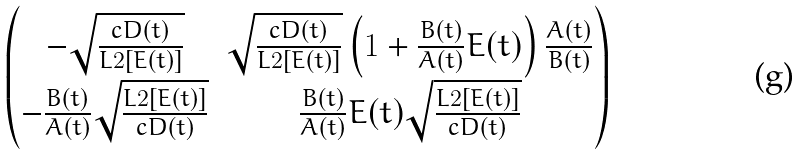<formula> <loc_0><loc_0><loc_500><loc_500>\begin{pmatrix} - \sqrt { \frac { c D ( t ) } { L 2 [ E ( t ) ] } } & \sqrt { \frac { c D ( t ) } { L 2 [ E ( t ) ] } } \left ( 1 + \frac { B ( t ) } { A ( t ) } E ( t ) \right ) \frac { A ( t ) } { B ( t ) } \\ - \frac { B ( t ) } { A ( t ) } \sqrt { \frac { L 2 [ E ( t ) ] } { c D ( t ) } } & \frac { B ( t ) } { A ( t ) } E ( t ) \sqrt { \frac { L 2 [ E ( t ) ] } { c D ( t ) } } \end{pmatrix}</formula> 